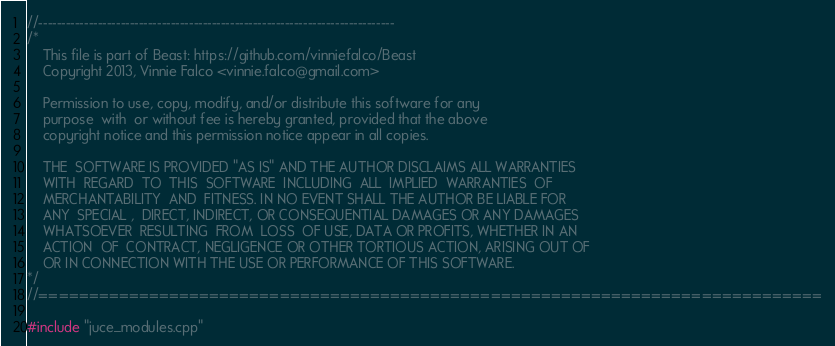Convert code to text. <code><loc_0><loc_0><loc_500><loc_500><_ObjectiveC_>//------------------------------------------------------------------------------
/*
	This file is part of Beast: https://github.com/vinniefalco/Beast
	Copyright 2013, Vinnie Falco <vinnie.falco@gmail.com>

	Permission to use, copy, modify, and/or distribute this software for any
	purpose  with  or without fee is hereby granted, provided that the above
	copyright notice and this permission notice appear in all copies.

	THE  SOFTWARE IS PROVIDED "AS IS" AND THE AUTHOR DISCLAIMS ALL WARRANTIES
	WITH  REGARD  TO  THIS  SOFTWARE  INCLUDING  ALL  IMPLIED  WARRANTIES  OF
	MERCHANTABILITY  AND  FITNESS. IN NO EVENT SHALL THE AUTHOR BE LIABLE FOR
	ANY  SPECIAL ,  DIRECT, INDIRECT, OR CONSEQUENTIAL DAMAGES OR ANY DAMAGES
	WHATSOEVER  RESULTING  FROM  LOSS  OF USE, DATA OR PROFITS, WHETHER IN AN
	ACTION  OF  CONTRACT, NEGLIGENCE OR OTHER TORTIOUS ACTION, ARISING OUT OF
	OR IN CONNECTION WITH THE USE OR PERFORMANCE OF THIS SOFTWARE.
*/
//==============================================================================

#include "juce_modules.cpp"
</code> 